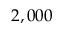Convert formula to latex. <formula><loc_0><loc_0><loc_500><loc_500>2 , 0 0 0</formula> 